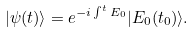Convert formula to latex. <formula><loc_0><loc_0><loc_500><loc_500>| \psi ( t ) \rangle = e ^ { - i \int ^ { t } E _ { 0 } } | E _ { 0 } ( t _ { 0 } ) \rangle .</formula> 